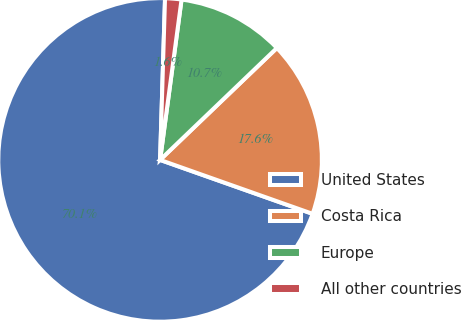<chart> <loc_0><loc_0><loc_500><loc_500><pie_chart><fcel>United States<fcel>Costa Rica<fcel>Europe<fcel>All other countries<nl><fcel>70.08%<fcel>17.57%<fcel>10.72%<fcel>1.63%<nl></chart> 